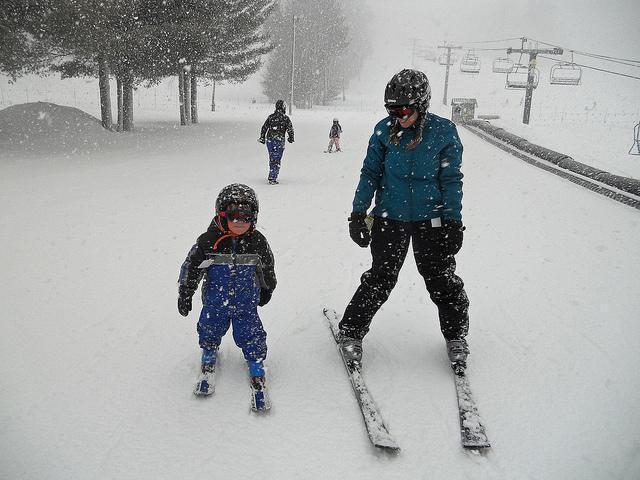What is the contraption on the right used for?
Choose the right answer and clarify with the format: 'Answer: answer
Rationale: rationale.'
Options: Climbing slopes, descending slopes, shoveling snow, creating snow. Answer: climbing slopes.
Rationale: There person on the right uses the contraption for climbing slopes. 